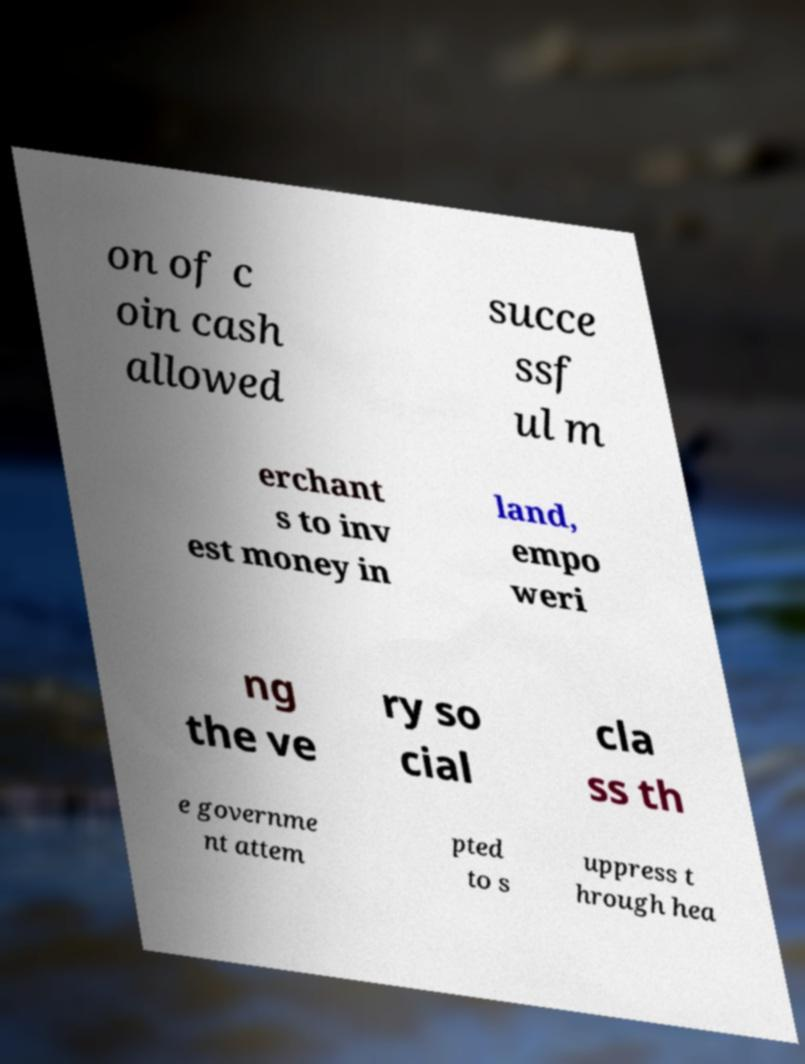Could you assist in decoding the text presented in this image and type it out clearly? on of c oin cash allowed succe ssf ul m erchant s to inv est money in land, empo weri ng the ve ry so cial cla ss th e governme nt attem pted to s uppress t hrough hea 